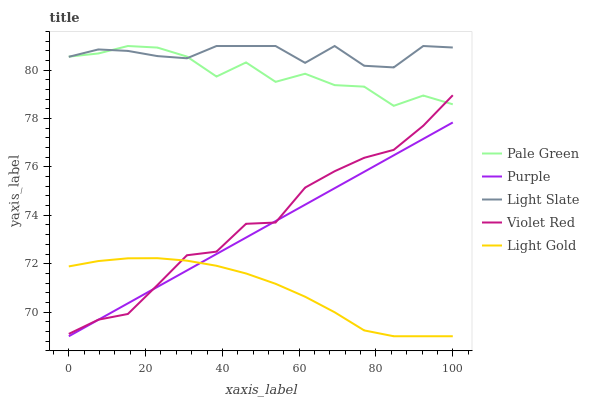Does Light Gold have the minimum area under the curve?
Answer yes or no. Yes. Does Light Slate have the maximum area under the curve?
Answer yes or no. Yes. Does Violet Red have the minimum area under the curve?
Answer yes or no. No. Does Violet Red have the maximum area under the curve?
Answer yes or no. No. Is Purple the smoothest?
Answer yes or no. Yes. Is Pale Green the roughest?
Answer yes or no. Yes. Is Light Slate the smoothest?
Answer yes or no. No. Is Light Slate the roughest?
Answer yes or no. No. Does Purple have the lowest value?
Answer yes or no. Yes. Does Violet Red have the lowest value?
Answer yes or no. No. Does Pale Green have the highest value?
Answer yes or no. Yes. Does Violet Red have the highest value?
Answer yes or no. No. Is Violet Red less than Light Slate?
Answer yes or no. Yes. Is Light Slate greater than Purple?
Answer yes or no. Yes. Does Violet Red intersect Pale Green?
Answer yes or no. Yes. Is Violet Red less than Pale Green?
Answer yes or no. No. Is Violet Red greater than Pale Green?
Answer yes or no. No. Does Violet Red intersect Light Slate?
Answer yes or no. No. 